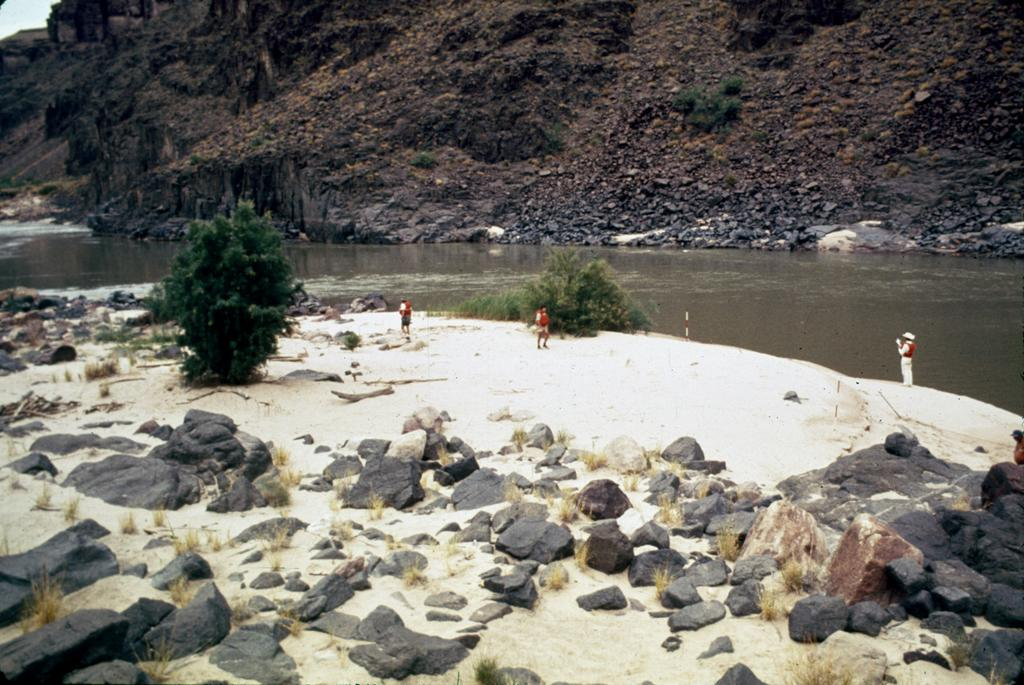How many people are in the image? There are people in the image, but the exact number is not specified. What type of terrain is visible in the image? The ground, stones, plants, grass, water, and hills are visible in the image, indicating a natural landscape. What part of the natural environment is visible in the image? The sky is visible in the image, providing context for the time of day or weather conditions. What type of coat is the squirrel wearing in the image? There is no squirrel present in the image, and therefore no coat to describe. How many blades of grass can be seen in the image? The exact number of blades of grass is not specified in the image, but we can see that there is grass present. 